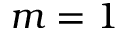Convert formula to latex. <formula><loc_0><loc_0><loc_500><loc_500>m = 1</formula> 